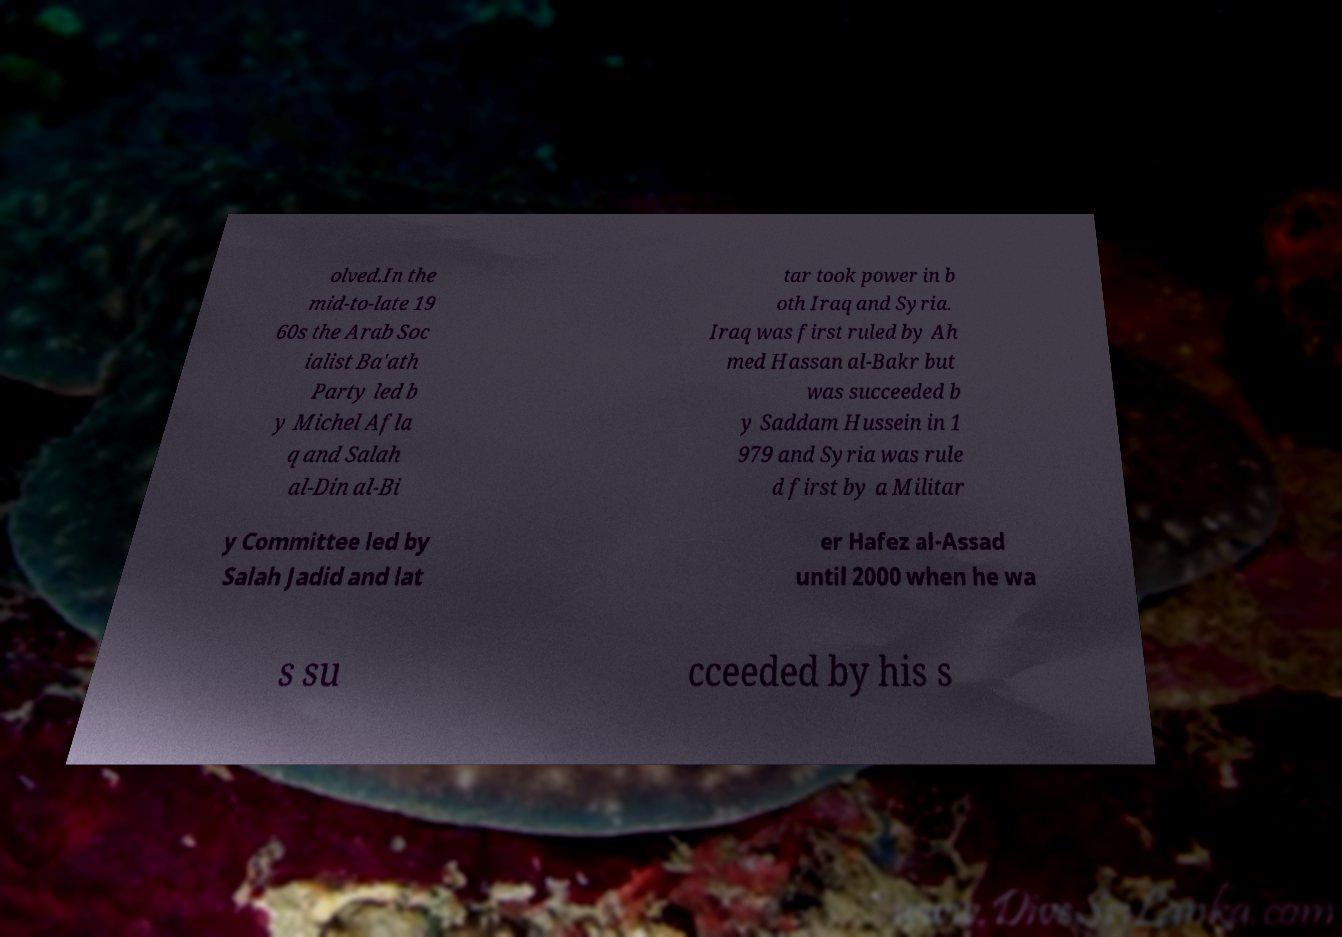Can you accurately transcribe the text from the provided image for me? olved.In the mid-to-late 19 60s the Arab Soc ialist Ba'ath Party led b y Michel Afla q and Salah al-Din al-Bi tar took power in b oth Iraq and Syria. Iraq was first ruled by Ah med Hassan al-Bakr but was succeeded b y Saddam Hussein in 1 979 and Syria was rule d first by a Militar y Committee led by Salah Jadid and lat er Hafez al-Assad until 2000 when he wa s su cceeded by his s 